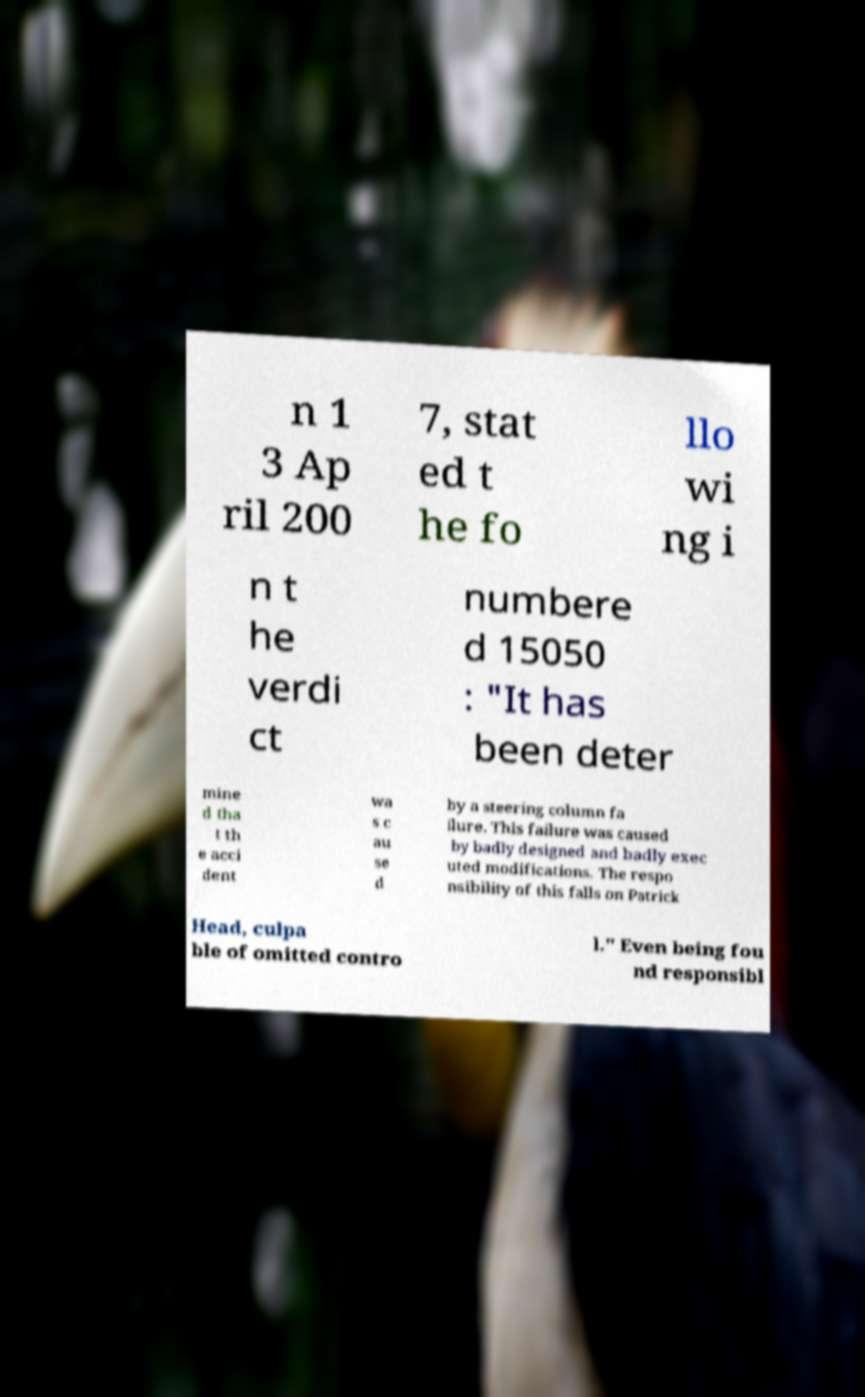Can you read and provide the text displayed in the image?This photo seems to have some interesting text. Can you extract and type it out for me? n 1 3 Ap ril 200 7, stat ed t he fo llo wi ng i n t he verdi ct numbere d 15050 : "It has been deter mine d tha t th e acci dent wa s c au se d by a steering column fa ilure. This failure was caused by badly designed and badly exec uted modifications. The respo nsibility of this falls on Patrick Head, culpa ble of omitted contro l." Even being fou nd responsibl 